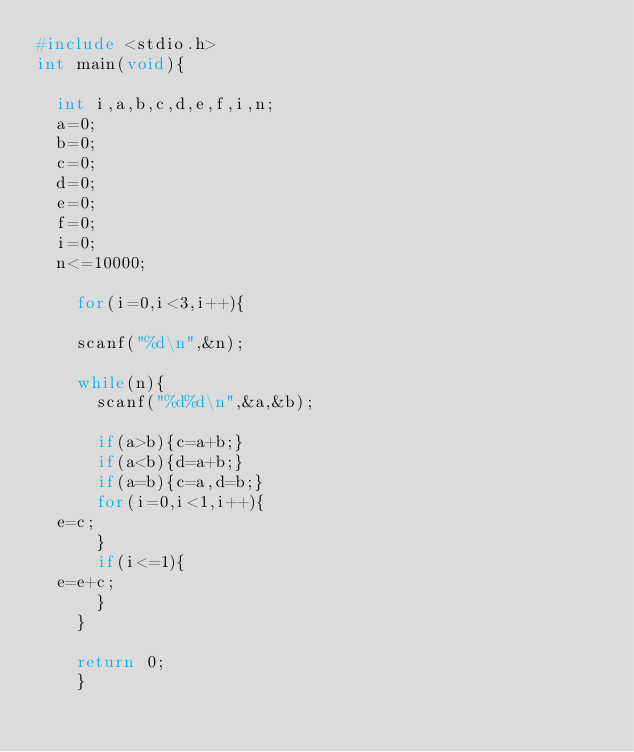<code> <loc_0><loc_0><loc_500><loc_500><_C_>#include <stdio.h>
int main(void){

  int i,a,b,c,d,e,f,i,n;
  a=0;
  b=0;
  c=0;
  d=0;
  e=0;
  f=0;
  i=0;
  n<=10000;
  
    for(i=0,i<3,i++){

    scanf("%d\n",&n);
    
    while(n){
      scanf("%d%d\n",&a,&b);
    
      if(a>b){c=a+b;}
      if(a<b){d=a+b;}
      if(a=b){c=a,d=b;}
      for(i=0,i<1,i++){
	e=c;
      }
      if(i<=1){
	e=e+c;
      }
    }

    return 0;
    }</code> 